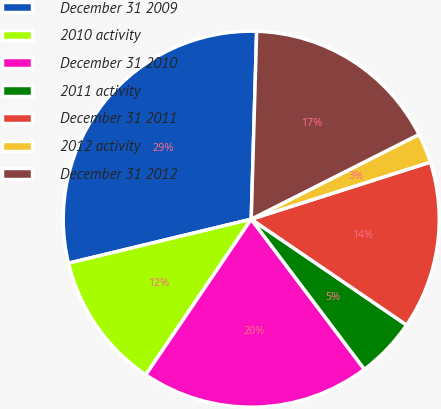Convert chart to OTSL. <chart><loc_0><loc_0><loc_500><loc_500><pie_chart><fcel>December 31 2009<fcel>2010 activity<fcel>December 31 2010<fcel>2011 activity<fcel>December 31 2011<fcel>2012 activity<fcel>December 31 2012<nl><fcel>29.22%<fcel>11.76%<fcel>19.76%<fcel>5.2%<fcel>14.43%<fcel>2.53%<fcel>17.1%<nl></chart> 